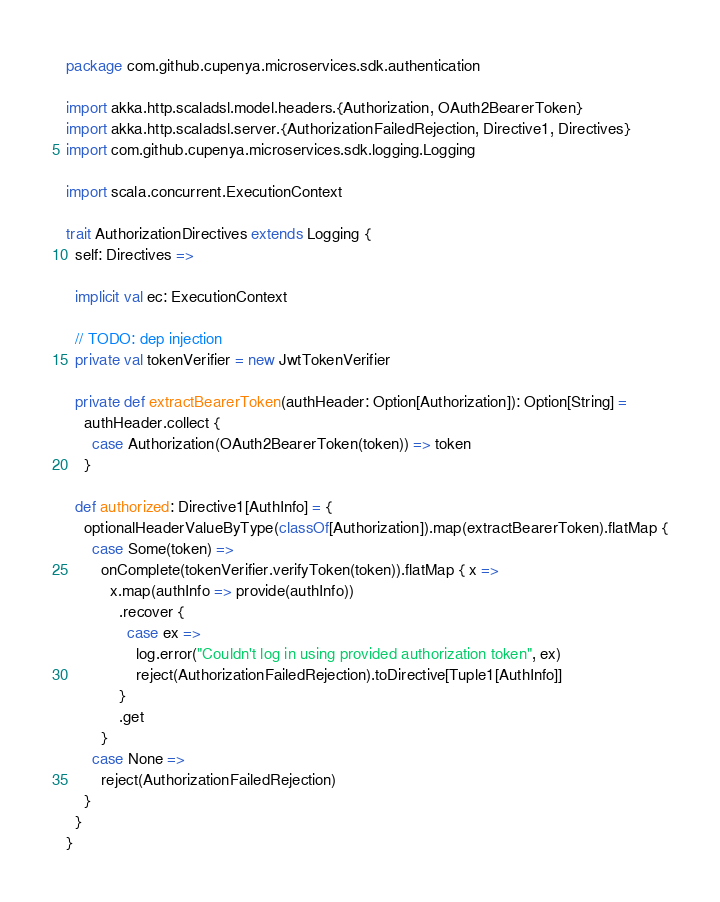<code> <loc_0><loc_0><loc_500><loc_500><_Scala_>package com.github.cupenya.microservices.sdk.authentication

import akka.http.scaladsl.model.headers.{Authorization, OAuth2BearerToken}
import akka.http.scaladsl.server.{AuthorizationFailedRejection, Directive1, Directives}
import com.github.cupenya.microservices.sdk.logging.Logging

import scala.concurrent.ExecutionContext

trait AuthorizationDirectives extends Logging {
  self: Directives =>

  implicit val ec: ExecutionContext

  // TODO: dep injection
  private val tokenVerifier = new JwtTokenVerifier

  private def extractBearerToken(authHeader: Option[Authorization]): Option[String] =
    authHeader.collect {
      case Authorization(OAuth2BearerToken(token)) => token
    }

  def authorized: Directive1[AuthInfo] = {
    optionalHeaderValueByType(classOf[Authorization]).map(extractBearerToken).flatMap {
      case Some(token) =>
        onComplete(tokenVerifier.verifyToken(token)).flatMap { x =>
          x.map(authInfo => provide(authInfo))
            .recover {
              case ex =>
                log.error("Couldn't log in using provided authorization token", ex)
                reject(AuthorizationFailedRejection).toDirective[Tuple1[AuthInfo]]
            }
            .get
        }
      case None =>
        reject(AuthorizationFailedRejection)
    }
  }
}
</code> 